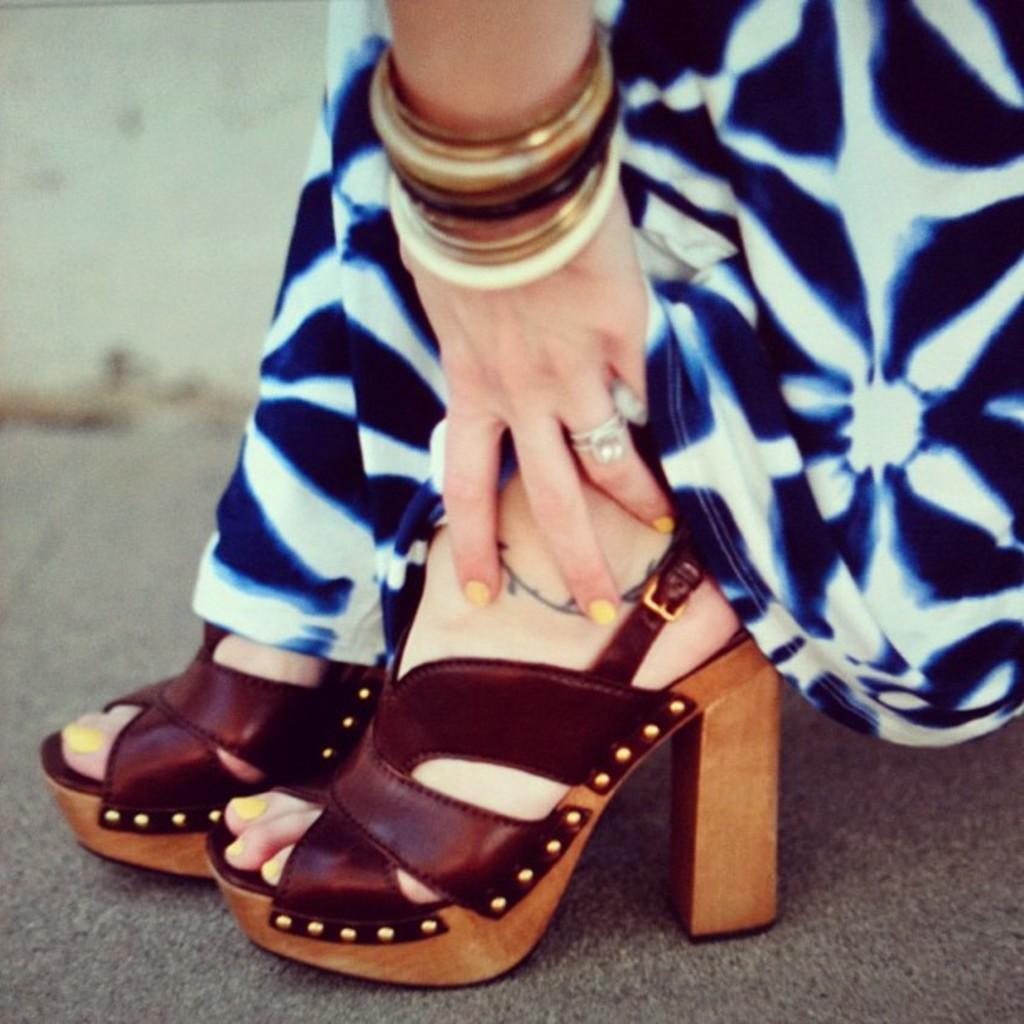What body parts of women are visible in the image? There are women's hands and legs visible in the image. Can you describe the position or action of the hands in the image? The provided facts do not give enough information to describe the position or action of the hands. Can you describe the position or action of the legs in the image? The provided facts do not give enough information to describe the position or action of the legs. What type of group is the women's hands and legs a part of in the image? The provided facts do not mention any group or context for the hands and legs in the image. What journey are the women's hands and legs taking in the image? The provided facts do not mention any journey or movement involving the hands and legs in the image. 